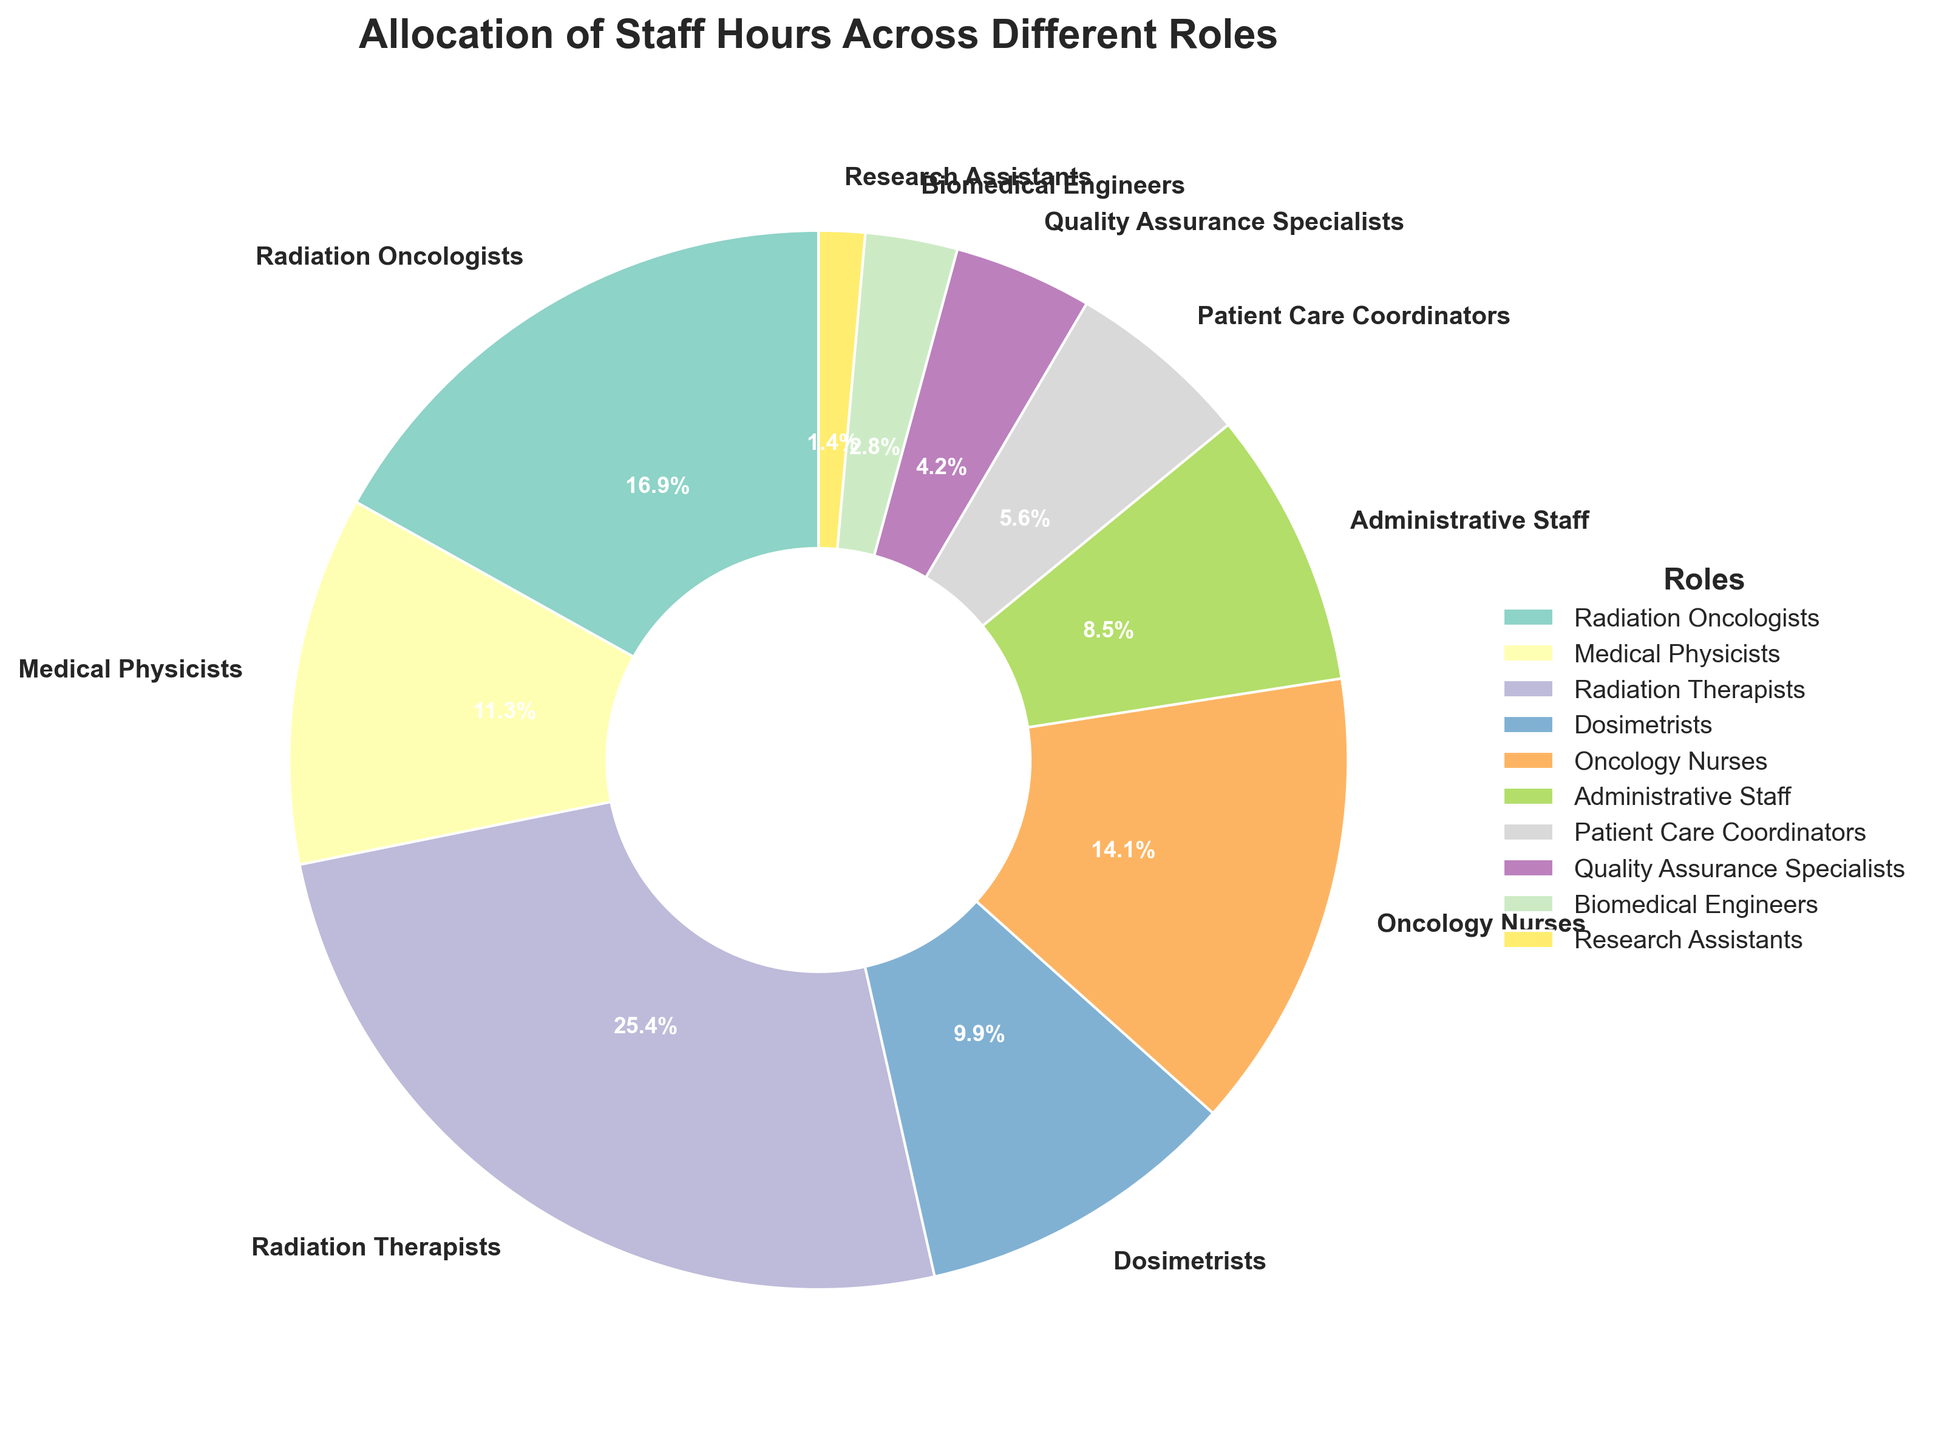What percentage of staff hours is allocated to Radiation Therapists? To find the percentage, look at the section labeled "Radiation Therapists" on the pie chart. The percentage for this role is directly shown next to the label.
Answer: 30.0% Which role has the fewest allocated staff hours and what is its percentage? Locate the smallest section in the pie chart. Identify the label and the percentage value next to it. The smallest section corresponds to "Research Assistants".
Answer: Research Assistants, 1.7% What is the cumulative percentage of allocated staff hours for Radiation Oncologists and Medical Physicists? Identify the percentages for Radiation Oncologists (20.0%) and Medical Physicists (13.3%) from the chart. Add these percentages together: 20.0% + 13.3% = 33.3%.
Answer: 33.3% Is the percentage of staff hours allocated to Oncology Nurses higher than that allocated to Dosimetrists? Compare the percentages of Oncology Nurses and Dosimetrists. The chart shows 16.7% for Oncology Nurses and 11.7% for Dosimetrists. 16.7% is higher than 11.7%.
Answer: Yes What is the difference in allocated staff hours between Radiation Therapists and Patient Care Coordinators? Find the percentages for Radiation Therapists (30.0%) and Patient Care Coordinators (6.7%). Calculate the difference: 30.0% - 6.7% = 23.3%.
Answer: 23.3% How much larger (in percentage points) is the allocation for Administrative Staff compared to Quality Assurance Specialists? Identify the percentages for Administrative Staff (10.0%) and Quality Assurance Specialists (5.0%). Subtract the smaller percentage from the larger one: 10.0% - 5.0% = 5.0%.
Answer: 5.0% What is the combined percentage of staff hours allocated to Biomedical Engineers and Research Assistants? Locate the percentages for Biomedical Engineers (3.3%) and Research Assistants (1.7%). Add these percentages: 3.3% + 1.7% = 5.0%.
Answer: 5.0% Which role takes up more staff hours: Dosimetrists or Medical Physicists? Compare the percentages for Dosimetrists (11.7%) and Medical Physicists (13.3%). 13.3% is greater than 11.7%, so Medical Physicists take up more staff hours.
Answer: Medical Physicists What are the percentages of the top three roles in terms of allocated staff hours, and what is their total percentage? Determine which three roles have the largest sections in the pie chart. These are Radiation Therapists (30.0%), Radiation Oncologists (20.0%), and Oncology Nurses (16.7%). Add these percentages together: 30.0% + 20.0% + 16.7% = 66.7%.
Answer: 30.0%, 20.0%, 16.7%, 66.7% How does the allocation of staff hours for Quality Assurance Specialists compare to the median value among all roles? To find the median, list the percentages in ascending order: 1.7%, 3.3%, 5.0%, 6.7%, 10.0%, 11.7%, 13.3%, 16.7%, 20.0%, 30.0%. The median is the average of the 5th and 6th values: (10.0% + 11.7%)/2 = 10.85%. Quality Assurance Specialists have 5.0%, which is less than the median value.
Answer: Less than the median 